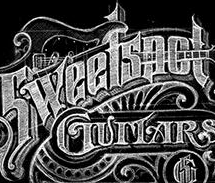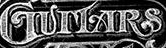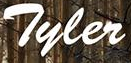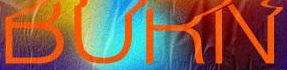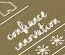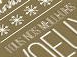Read the text content from these images in order, separated by a semicolon. Sweetspot; GUITARS; Tyler; BURN; #; # 